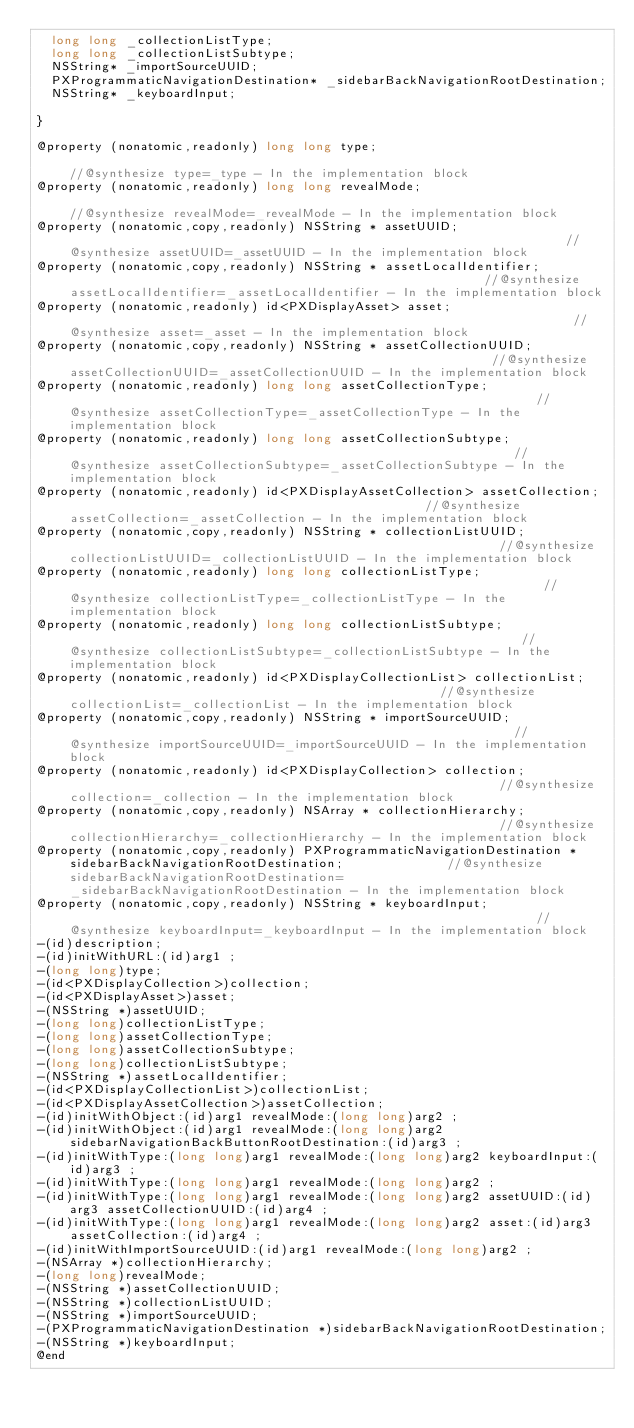Convert code to text. <code><loc_0><loc_0><loc_500><loc_500><_C_>	long long _collectionListType;
	long long _collectionListSubtype;
	NSString* _importSourceUUID;
	PXProgrammaticNavigationDestination* _sidebarBackNavigationRootDestination;
	NSString* _keyboardInput;

}

@property (nonatomic,readonly) long long type;                                                                               //@synthesize type=_type - In the implementation block
@property (nonatomic,readonly) long long revealMode;                                                                         //@synthesize revealMode=_revealMode - In the implementation block
@property (nonatomic,copy,readonly) NSString * assetUUID;                                                                    //@synthesize assetUUID=_assetUUID - In the implementation block
@property (nonatomic,copy,readonly) NSString * assetLocalIdentifier;                                                         //@synthesize assetLocalIdentifier=_assetLocalIdentifier - In the implementation block
@property (nonatomic,readonly) id<PXDisplayAsset> asset;                                                                     //@synthesize asset=_asset - In the implementation block
@property (nonatomic,copy,readonly) NSString * assetCollectionUUID;                                                          //@synthesize assetCollectionUUID=_assetCollectionUUID - In the implementation block
@property (nonatomic,readonly) long long assetCollectionType;                                                                //@synthesize assetCollectionType=_assetCollectionType - In the implementation block
@property (nonatomic,readonly) long long assetCollectionSubtype;                                                             //@synthesize assetCollectionSubtype=_assetCollectionSubtype - In the implementation block
@property (nonatomic,readonly) id<PXDisplayAssetCollection> assetCollection;                                                 //@synthesize assetCollection=_assetCollection - In the implementation block
@property (nonatomic,copy,readonly) NSString * collectionListUUID;                                                           //@synthesize collectionListUUID=_collectionListUUID - In the implementation block
@property (nonatomic,readonly) long long collectionListType;                                                                 //@synthesize collectionListType=_collectionListType - In the implementation block
@property (nonatomic,readonly) long long collectionListSubtype;                                                              //@synthesize collectionListSubtype=_collectionListSubtype - In the implementation block
@property (nonatomic,readonly) id<PXDisplayCollectionList> collectionList;                                                   //@synthesize collectionList=_collectionList - In the implementation block
@property (nonatomic,copy,readonly) NSString * importSourceUUID;                                                             //@synthesize importSourceUUID=_importSourceUUID - In the implementation block
@property (nonatomic,readonly) id<PXDisplayCollection> collection;                                                           //@synthesize collection=_collection - In the implementation block
@property (nonatomic,copy,readonly) NSArray * collectionHierarchy;                                                           //@synthesize collectionHierarchy=_collectionHierarchy - In the implementation block
@property (nonatomic,copy,readonly) PXProgrammaticNavigationDestination * sidebarBackNavigationRootDestination;              //@synthesize sidebarBackNavigationRootDestination=_sidebarBackNavigationRootDestination - In the implementation block
@property (nonatomic,copy,readonly) NSString * keyboardInput;                                                                //@synthesize keyboardInput=_keyboardInput - In the implementation block
-(id)description;
-(id)initWithURL:(id)arg1 ;
-(long long)type;
-(id<PXDisplayCollection>)collection;
-(id<PXDisplayAsset>)asset;
-(NSString *)assetUUID;
-(long long)collectionListType;
-(long long)assetCollectionType;
-(long long)assetCollectionSubtype;
-(long long)collectionListSubtype;
-(NSString *)assetLocalIdentifier;
-(id<PXDisplayCollectionList>)collectionList;
-(id<PXDisplayAssetCollection>)assetCollection;
-(id)initWithObject:(id)arg1 revealMode:(long long)arg2 ;
-(id)initWithObject:(id)arg1 revealMode:(long long)arg2 sidebarNavigationBackButtonRootDestination:(id)arg3 ;
-(id)initWithType:(long long)arg1 revealMode:(long long)arg2 keyboardInput:(id)arg3 ;
-(id)initWithType:(long long)arg1 revealMode:(long long)arg2 ;
-(id)initWithType:(long long)arg1 revealMode:(long long)arg2 assetUUID:(id)arg3 assetCollectionUUID:(id)arg4 ;
-(id)initWithType:(long long)arg1 revealMode:(long long)arg2 asset:(id)arg3 assetCollection:(id)arg4 ;
-(id)initWithImportSourceUUID:(id)arg1 revealMode:(long long)arg2 ;
-(NSArray *)collectionHierarchy;
-(long long)revealMode;
-(NSString *)assetCollectionUUID;
-(NSString *)collectionListUUID;
-(NSString *)importSourceUUID;
-(PXProgrammaticNavigationDestination *)sidebarBackNavigationRootDestination;
-(NSString *)keyboardInput;
@end

</code> 